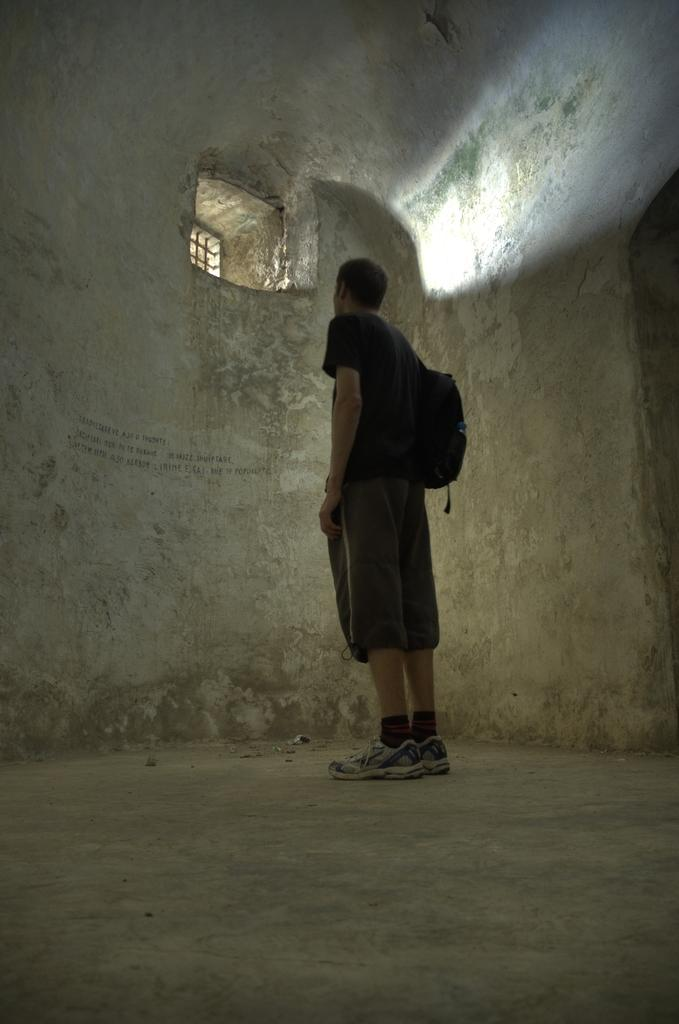What is the main subject of the image? There is a person in the image. What is the person wearing on their upper body? The person is wearing a black t-shirt. What is the person carrying on their back? The person is wearing a black backpack. What surface is the person standing on? The person is standing on the floor. What type of architectural feature can be seen in the image? There is a wall and a window visible in the image. What type of debt is the person discussing in the image? There is no indication in the image that the person is discussing debt or any financial matters. What type of operation is the person performing in the image? There is no operation or any medical procedure being performed in the image; the person is simply standing. 